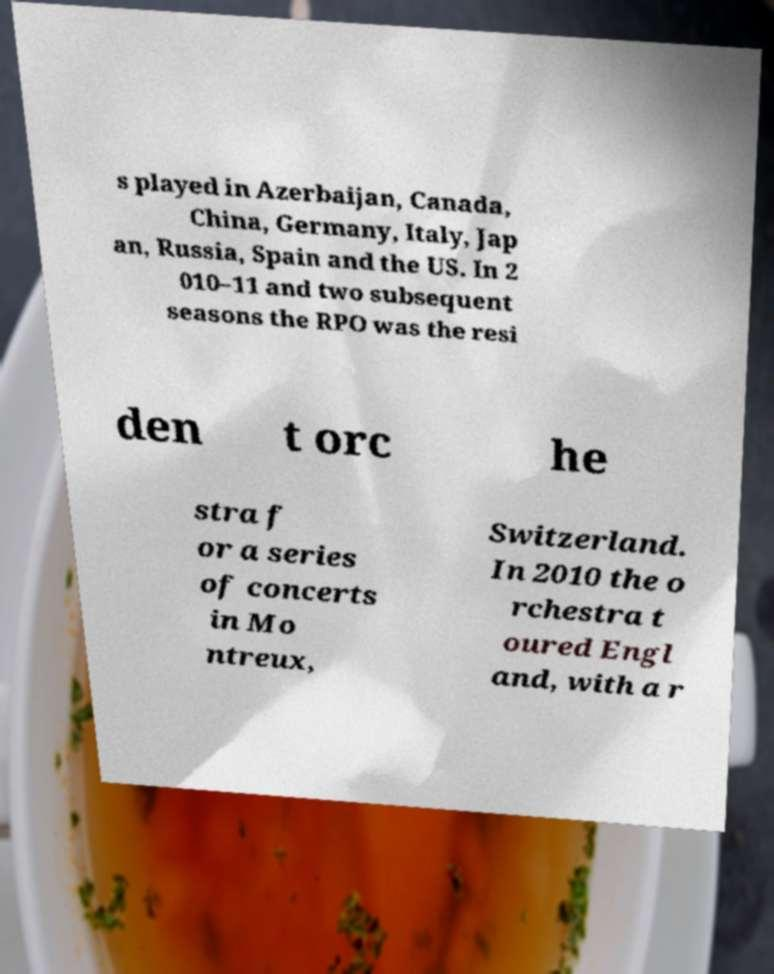Please identify and transcribe the text found in this image. s played in Azerbaijan, Canada, China, Germany, Italy, Jap an, Russia, Spain and the US. In 2 010–11 and two subsequent seasons the RPO was the resi den t orc he stra f or a series of concerts in Mo ntreux, Switzerland. In 2010 the o rchestra t oured Engl and, with a r 